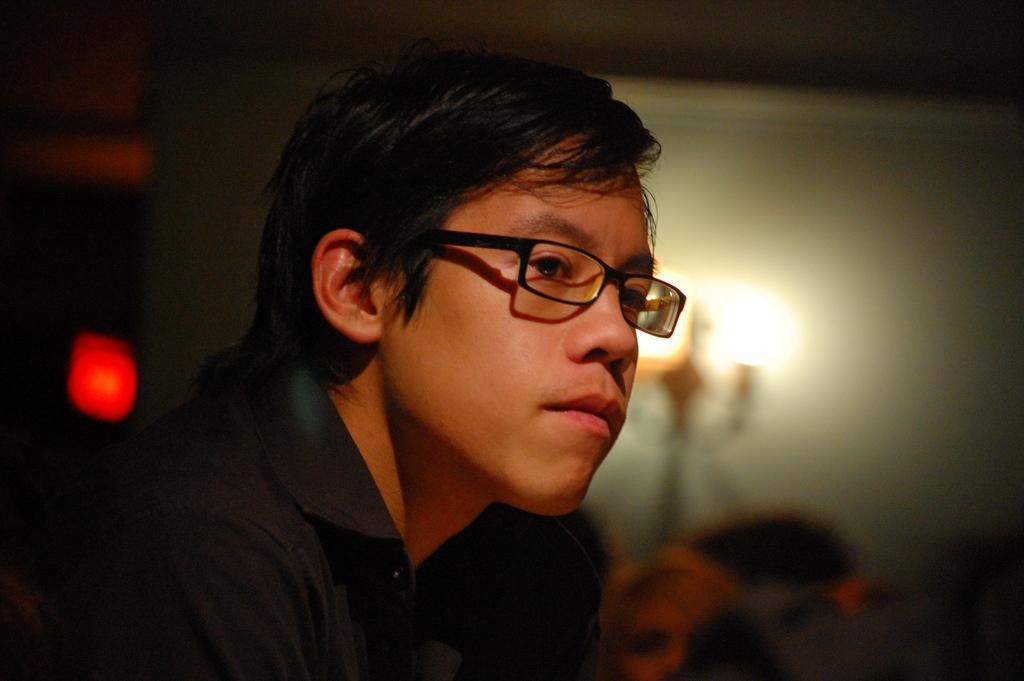Describe this image in one or two sentences. In this in the foreground there is a person wearing a spectacle, in the background there may be the wall, in front of the wall there are lights visible, on the left side there is a light focus visible. 